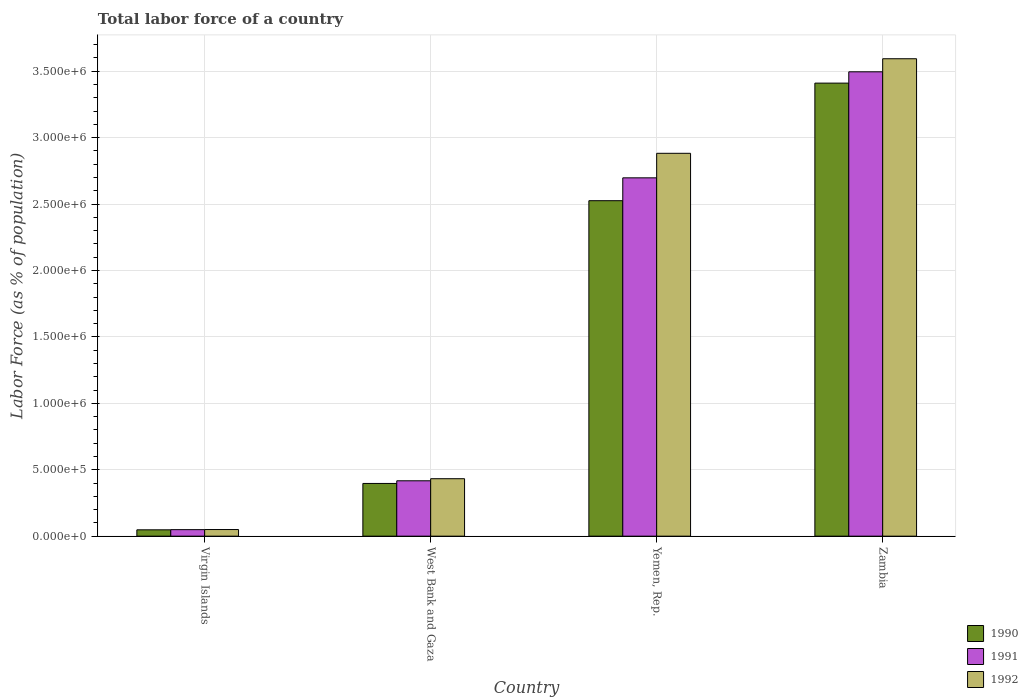How many different coloured bars are there?
Provide a succinct answer. 3. Are the number of bars per tick equal to the number of legend labels?
Ensure brevity in your answer.  Yes. How many bars are there on the 4th tick from the right?
Your answer should be compact. 3. What is the label of the 3rd group of bars from the left?
Your response must be concise. Yemen, Rep. In how many cases, is the number of bars for a given country not equal to the number of legend labels?
Offer a very short reply. 0. What is the percentage of labor force in 1990 in Zambia?
Make the answer very short. 3.41e+06. Across all countries, what is the maximum percentage of labor force in 1991?
Your response must be concise. 3.50e+06. Across all countries, what is the minimum percentage of labor force in 1990?
Offer a terse response. 4.78e+04. In which country was the percentage of labor force in 1990 maximum?
Make the answer very short. Zambia. In which country was the percentage of labor force in 1991 minimum?
Ensure brevity in your answer.  Virgin Islands. What is the total percentage of labor force in 1992 in the graph?
Keep it short and to the point. 6.96e+06. What is the difference between the percentage of labor force in 1992 in Virgin Islands and that in Zambia?
Offer a very short reply. -3.54e+06. What is the difference between the percentage of labor force in 1992 in Virgin Islands and the percentage of labor force in 1991 in Zambia?
Ensure brevity in your answer.  -3.45e+06. What is the average percentage of labor force in 1990 per country?
Keep it short and to the point. 1.60e+06. What is the difference between the percentage of labor force of/in 1991 and percentage of labor force of/in 1990 in West Bank and Gaza?
Make the answer very short. 2.01e+04. What is the ratio of the percentage of labor force in 1990 in Virgin Islands to that in Yemen, Rep.?
Provide a short and direct response. 0.02. What is the difference between the highest and the second highest percentage of labor force in 1991?
Offer a terse response. 7.98e+05. What is the difference between the highest and the lowest percentage of labor force in 1990?
Keep it short and to the point. 3.36e+06. Is the sum of the percentage of labor force in 1992 in West Bank and Gaza and Zambia greater than the maximum percentage of labor force in 1990 across all countries?
Keep it short and to the point. Yes. What does the 2nd bar from the left in Yemen, Rep. represents?
Your answer should be compact. 1991. How many bars are there?
Your answer should be compact. 12. How many countries are there in the graph?
Offer a terse response. 4. What is the difference between two consecutive major ticks on the Y-axis?
Provide a short and direct response. 5.00e+05. Are the values on the major ticks of Y-axis written in scientific E-notation?
Your answer should be very brief. Yes. Does the graph contain any zero values?
Offer a very short reply. No. Does the graph contain grids?
Your response must be concise. Yes. Where does the legend appear in the graph?
Your answer should be very brief. Bottom right. How are the legend labels stacked?
Provide a succinct answer. Vertical. What is the title of the graph?
Give a very brief answer. Total labor force of a country. What is the label or title of the Y-axis?
Offer a very short reply. Labor Force (as % of population). What is the Labor Force (as % of population) in 1990 in Virgin Islands?
Make the answer very short. 4.78e+04. What is the Labor Force (as % of population) of 1991 in Virgin Islands?
Offer a very short reply. 4.91e+04. What is the Labor Force (as % of population) of 1992 in Virgin Islands?
Provide a short and direct response. 5.00e+04. What is the Labor Force (as % of population) of 1990 in West Bank and Gaza?
Provide a short and direct response. 3.97e+05. What is the Labor Force (as % of population) of 1991 in West Bank and Gaza?
Provide a short and direct response. 4.17e+05. What is the Labor Force (as % of population) in 1992 in West Bank and Gaza?
Offer a terse response. 4.33e+05. What is the Labor Force (as % of population) of 1990 in Yemen, Rep.?
Your response must be concise. 2.53e+06. What is the Labor Force (as % of population) of 1991 in Yemen, Rep.?
Your answer should be compact. 2.70e+06. What is the Labor Force (as % of population) of 1992 in Yemen, Rep.?
Your answer should be very brief. 2.88e+06. What is the Labor Force (as % of population) of 1990 in Zambia?
Keep it short and to the point. 3.41e+06. What is the Labor Force (as % of population) of 1991 in Zambia?
Ensure brevity in your answer.  3.50e+06. What is the Labor Force (as % of population) in 1992 in Zambia?
Make the answer very short. 3.59e+06. Across all countries, what is the maximum Labor Force (as % of population) in 1990?
Offer a very short reply. 3.41e+06. Across all countries, what is the maximum Labor Force (as % of population) of 1991?
Offer a terse response. 3.50e+06. Across all countries, what is the maximum Labor Force (as % of population) in 1992?
Give a very brief answer. 3.59e+06. Across all countries, what is the minimum Labor Force (as % of population) of 1990?
Your answer should be very brief. 4.78e+04. Across all countries, what is the minimum Labor Force (as % of population) of 1991?
Provide a short and direct response. 4.91e+04. Across all countries, what is the minimum Labor Force (as % of population) in 1992?
Offer a terse response. 5.00e+04. What is the total Labor Force (as % of population) in 1990 in the graph?
Your response must be concise. 6.38e+06. What is the total Labor Force (as % of population) of 1991 in the graph?
Ensure brevity in your answer.  6.66e+06. What is the total Labor Force (as % of population) of 1992 in the graph?
Give a very brief answer. 6.96e+06. What is the difference between the Labor Force (as % of population) of 1990 in Virgin Islands and that in West Bank and Gaza?
Offer a terse response. -3.49e+05. What is the difference between the Labor Force (as % of population) of 1991 in Virgin Islands and that in West Bank and Gaza?
Provide a succinct answer. -3.68e+05. What is the difference between the Labor Force (as % of population) in 1992 in Virgin Islands and that in West Bank and Gaza?
Your answer should be compact. -3.83e+05. What is the difference between the Labor Force (as % of population) of 1990 in Virgin Islands and that in Yemen, Rep.?
Offer a terse response. -2.48e+06. What is the difference between the Labor Force (as % of population) of 1991 in Virgin Islands and that in Yemen, Rep.?
Provide a short and direct response. -2.65e+06. What is the difference between the Labor Force (as % of population) of 1992 in Virgin Islands and that in Yemen, Rep.?
Give a very brief answer. -2.83e+06. What is the difference between the Labor Force (as % of population) of 1990 in Virgin Islands and that in Zambia?
Give a very brief answer. -3.36e+06. What is the difference between the Labor Force (as % of population) in 1991 in Virgin Islands and that in Zambia?
Your answer should be compact. -3.45e+06. What is the difference between the Labor Force (as % of population) of 1992 in Virgin Islands and that in Zambia?
Keep it short and to the point. -3.54e+06. What is the difference between the Labor Force (as % of population) in 1990 in West Bank and Gaza and that in Yemen, Rep.?
Provide a short and direct response. -2.13e+06. What is the difference between the Labor Force (as % of population) of 1991 in West Bank and Gaza and that in Yemen, Rep.?
Keep it short and to the point. -2.28e+06. What is the difference between the Labor Force (as % of population) in 1992 in West Bank and Gaza and that in Yemen, Rep.?
Give a very brief answer. -2.45e+06. What is the difference between the Labor Force (as % of population) of 1990 in West Bank and Gaza and that in Zambia?
Provide a short and direct response. -3.01e+06. What is the difference between the Labor Force (as % of population) in 1991 in West Bank and Gaza and that in Zambia?
Provide a short and direct response. -3.08e+06. What is the difference between the Labor Force (as % of population) in 1992 in West Bank and Gaza and that in Zambia?
Give a very brief answer. -3.16e+06. What is the difference between the Labor Force (as % of population) of 1990 in Yemen, Rep. and that in Zambia?
Give a very brief answer. -8.85e+05. What is the difference between the Labor Force (as % of population) in 1991 in Yemen, Rep. and that in Zambia?
Offer a very short reply. -7.98e+05. What is the difference between the Labor Force (as % of population) in 1992 in Yemen, Rep. and that in Zambia?
Your answer should be very brief. -7.12e+05. What is the difference between the Labor Force (as % of population) in 1990 in Virgin Islands and the Labor Force (as % of population) in 1991 in West Bank and Gaza?
Keep it short and to the point. -3.69e+05. What is the difference between the Labor Force (as % of population) of 1990 in Virgin Islands and the Labor Force (as % of population) of 1992 in West Bank and Gaza?
Offer a terse response. -3.85e+05. What is the difference between the Labor Force (as % of population) in 1991 in Virgin Islands and the Labor Force (as % of population) in 1992 in West Bank and Gaza?
Your response must be concise. -3.83e+05. What is the difference between the Labor Force (as % of population) in 1990 in Virgin Islands and the Labor Force (as % of population) in 1991 in Yemen, Rep.?
Your answer should be very brief. -2.65e+06. What is the difference between the Labor Force (as % of population) of 1990 in Virgin Islands and the Labor Force (as % of population) of 1992 in Yemen, Rep.?
Keep it short and to the point. -2.83e+06. What is the difference between the Labor Force (as % of population) of 1991 in Virgin Islands and the Labor Force (as % of population) of 1992 in Yemen, Rep.?
Ensure brevity in your answer.  -2.83e+06. What is the difference between the Labor Force (as % of population) in 1990 in Virgin Islands and the Labor Force (as % of population) in 1991 in Zambia?
Provide a succinct answer. -3.45e+06. What is the difference between the Labor Force (as % of population) in 1990 in Virgin Islands and the Labor Force (as % of population) in 1992 in Zambia?
Keep it short and to the point. -3.55e+06. What is the difference between the Labor Force (as % of population) in 1991 in Virgin Islands and the Labor Force (as % of population) in 1992 in Zambia?
Ensure brevity in your answer.  -3.55e+06. What is the difference between the Labor Force (as % of population) of 1990 in West Bank and Gaza and the Labor Force (as % of population) of 1991 in Yemen, Rep.?
Make the answer very short. -2.30e+06. What is the difference between the Labor Force (as % of population) of 1990 in West Bank and Gaza and the Labor Force (as % of population) of 1992 in Yemen, Rep.?
Give a very brief answer. -2.49e+06. What is the difference between the Labor Force (as % of population) of 1991 in West Bank and Gaza and the Labor Force (as % of population) of 1992 in Yemen, Rep.?
Your answer should be very brief. -2.47e+06. What is the difference between the Labor Force (as % of population) of 1990 in West Bank and Gaza and the Labor Force (as % of population) of 1991 in Zambia?
Offer a terse response. -3.10e+06. What is the difference between the Labor Force (as % of population) of 1990 in West Bank and Gaza and the Labor Force (as % of population) of 1992 in Zambia?
Offer a terse response. -3.20e+06. What is the difference between the Labor Force (as % of population) in 1991 in West Bank and Gaza and the Labor Force (as % of population) in 1992 in Zambia?
Provide a succinct answer. -3.18e+06. What is the difference between the Labor Force (as % of population) in 1990 in Yemen, Rep. and the Labor Force (as % of population) in 1991 in Zambia?
Provide a succinct answer. -9.70e+05. What is the difference between the Labor Force (as % of population) in 1990 in Yemen, Rep. and the Labor Force (as % of population) in 1992 in Zambia?
Ensure brevity in your answer.  -1.07e+06. What is the difference between the Labor Force (as % of population) of 1991 in Yemen, Rep. and the Labor Force (as % of population) of 1992 in Zambia?
Offer a terse response. -8.97e+05. What is the average Labor Force (as % of population) in 1990 per country?
Offer a very short reply. 1.60e+06. What is the average Labor Force (as % of population) of 1991 per country?
Provide a succinct answer. 1.66e+06. What is the average Labor Force (as % of population) in 1992 per country?
Make the answer very short. 1.74e+06. What is the difference between the Labor Force (as % of population) of 1990 and Labor Force (as % of population) of 1991 in Virgin Islands?
Your answer should be compact. -1288. What is the difference between the Labor Force (as % of population) of 1990 and Labor Force (as % of population) of 1992 in Virgin Islands?
Your response must be concise. -2120. What is the difference between the Labor Force (as % of population) of 1991 and Labor Force (as % of population) of 1992 in Virgin Islands?
Make the answer very short. -832. What is the difference between the Labor Force (as % of population) in 1990 and Labor Force (as % of population) in 1991 in West Bank and Gaza?
Your answer should be very brief. -2.01e+04. What is the difference between the Labor Force (as % of population) of 1990 and Labor Force (as % of population) of 1992 in West Bank and Gaza?
Your response must be concise. -3.56e+04. What is the difference between the Labor Force (as % of population) of 1991 and Labor Force (as % of population) of 1992 in West Bank and Gaza?
Offer a very short reply. -1.56e+04. What is the difference between the Labor Force (as % of population) in 1990 and Labor Force (as % of population) in 1991 in Yemen, Rep.?
Your answer should be very brief. -1.72e+05. What is the difference between the Labor Force (as % of population) in 1990 and Labor Force (as % of population) in 1992 in Yemen, Rep.?
Offer a terse response. -3.57e+05. What is the difference between the Labor Force (as % of population) of 1991 and Labor Force (as % of population) of 1992 in Yemen, Rep.?
Your answer should be compact. -1.85e+05. What is the difference between the Labor Force (as % of population) of 1990 and Labor Force (as % of population) of 1991 in Zambia?
Your response must be concise. -8.52e+04. What is the difference between the Labor Force (as % of population) in 1990 and Labor Force (as % of population) in 1992 in Zambia?
Keep it short and to the point. -1.83e+05. What is the difference between the Labor Force (as % of population) of 1991 and Labor Force (as % of population) of 1992 in Zambia?
Give a very brief answer. -9.83e+04. What is the ratio of the Labor Force (as % of population) of 1990 in Virgin Islands to that in West Bank and Gaza?
Ensure brevity in your answer.  0.12. What is the ratio of the Labor Force (as % of population) in 1991 in Virgin Islands to that in West Bank and Gaza?
Your response must be concise. 0.12. What is the ratio of the Labor Force (as % of population) of 1992 in Virgin Islands to that in West Bank and Gaza?
Your response must be concise. 0.12. What is the ratio of the Labor Force (as % of population) of 1990 in Virgin Islands to that in Yemen, Rep.?
Provide a succinct answer. 0.02. What is the ratio of the Labor Force (as % of population) of 1991 in Virgin Islands to that in Yemen, Rep.?
Your answer should be compact. 0.02. What is the ratio of the Labor Force (as % of population) of 1992 in Virgin Islands to that in Yemen, Rep.?
Your answer should be compact. 0.02. What is the ratio of the Labor Force (as % of population) in 1990 in Virgin Islands to that in Zambia?
Your answer should be compact. 0.01. What is the ratio of the Labor Force (as % of population) of 1991 in Virgin Islands to that in Zambia?
Keep it short and to the point. 0.01. What is the ratio of the Labor Force (as % of population) in 1992 in Virgin Islands to that in Zambia?
Offer a very short reply. 0.01. What is the ratio of the Labor Force (as % of population) in 1990 in West Bank and Gaza to that in Yemen, Rep.?
Make the answer very short. 0.16. What is the ratio of the Labor Force (as % of population) in 1991 in West Bank and Gaza to that in Yemen, Rep.?
Your answer should be very brief. 0.15. What is the ratio of the Labor Force (as % of population) in 1992 in West Bank and Gaza to that in Yemen, Rep.?
Make the answer very short. 0.15. What is the ratio of the Labor Force (as % of population) in 1990 in West Bank and Gaza to that in Zambia?
Make the answer very short. 0.12. What is the ratio of the Labor Force (as % of population) of 1991 in West Bank and Gaza to that in Zambia?
Your answer should be very brief. 0.12. What is the ratio of the Labor Force (as % of population) in 1992 in West Bank and Gaza to that in Zambia?
Keep it short and to the point. 0.12. What is the ratio of the Labor Force (as % of population) in 1990 in Yemen, Rep. to that in Zambia?
Your response must be concise. 0.74. What is the ratio of the Labor Force (as % of population) in 1991 in Yemen, Rep. to that in Zambia?
Give a very brief answer. 0.77. What is the ratio of the Labor Force (as % of population) of 1992 in Yemen, Rep. to that in Zambia?
Offer a very short reply. 0.8. What is the difference between the highest and the second highest Labor Force (as % of population) of 1990?
Give a very brief answer. 8.85e+05. What is the difference between the highest and the second highest Labor Force (as % of population) in 1991?
Provide a succinct answer. 7.98e+05. What is the difference between the highest and the second highest Labor Force (as % of population) in 1992?
Your answer should be very brief. 7.12e+05. What is the difference between the highest and the lowest Labor Force (as % of population) of 1990?
Provide a short and direct response. 3.36e+06. What is the difference between the highest and the lowest Labor Force (as % of population) of 1991?
Offer a terse response. 3.45e+06. What is the difference between the highest and the lowest Labor Force (as % of population) of 1992?
Ensure brevity in your answer.  3.54e+06. 